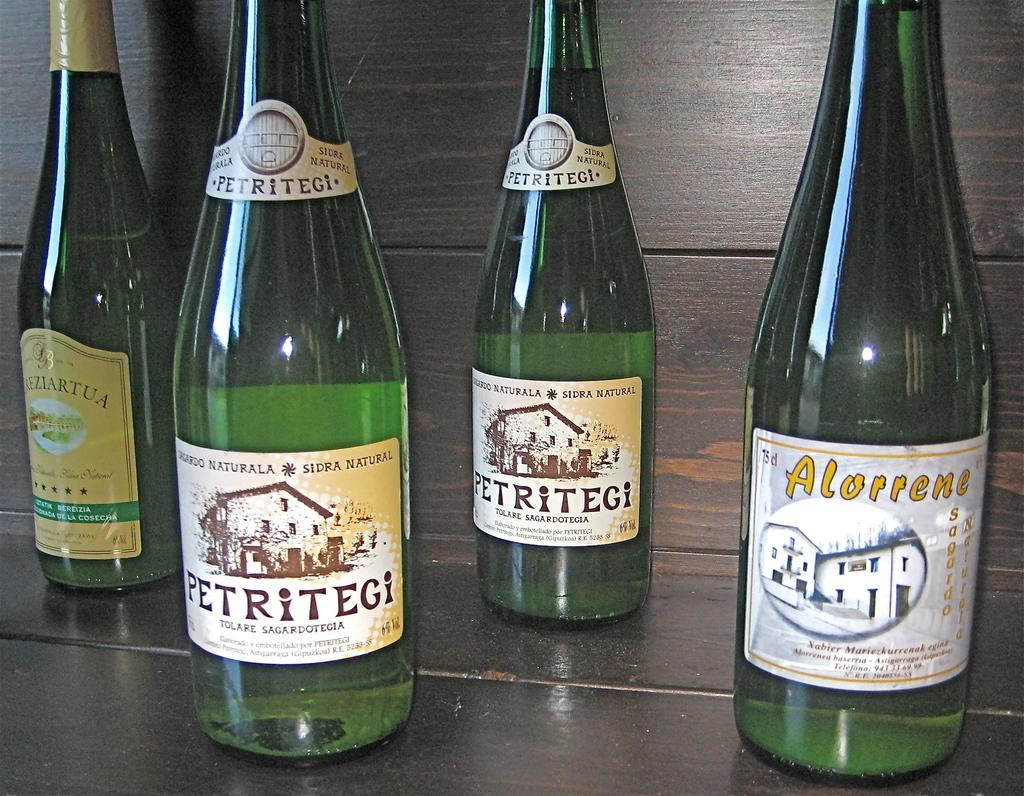<image>
Provide a brief description of the given image. Bottles of various wins including petritegi and alorrene 